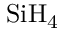<formula> <loc_0><loc_0><loc_500><loc_500>S i H _ { 4 }</formula> 